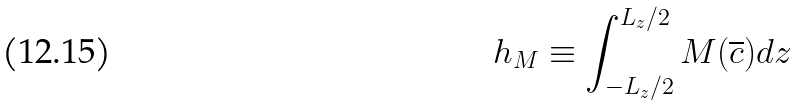<formula> <loc_0><loc_0><loc_500><loc_500>h _ { M } \equiv \int _ { - L _ { z } / 2 } ^ { L _ { z } / 2 } M ( \overline { c } ) d z</formula> 